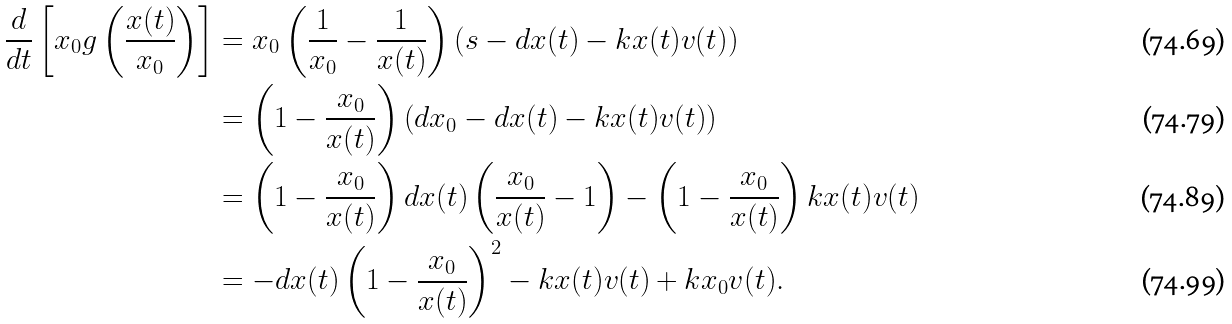Convert formula to latex. <formula><loc_0><loc_0><loc_500><loc_500>\frac { d } { d t } \left [ x _ { 0 } g \left ( \frac { x ( t ) } { x _ { 0 } } \right ) \right ] & = x _ { 0 } \left ( \frac { 1 } { x _ { 0 } } - \frac { 1 } { x ( t ) } \right ) \left ( s - d x ( t ) - k x ( t ) v ( t ) \right ) \\ & = \left ( 1 - \frac { x _ { 0 } } { x ( t ) } \right ) \left ( d x _ { 0 } - d x ( t ) - k x ( t ) v ( t ) \right ) \\ & = \left ( 1 - \frac { x _ { 0 } } { x ( t ) } \right ) d x ( t ) \left ( \frac { x _ { 0 } } { x ( t ) } - 1 \right ) - \left ( 1 - \frac { x _ { 0 } } { x ( t ) } \right ) k x ( t ) v ( t ) \\ & = - d x ( t ) \left ( 1 - \frac { x _ { 0 } } { x ( t ) } \right ) ^ { 2 } - k x ( t ) v ( t ) + k x _ { 0 } v ( t ) .</formula> 